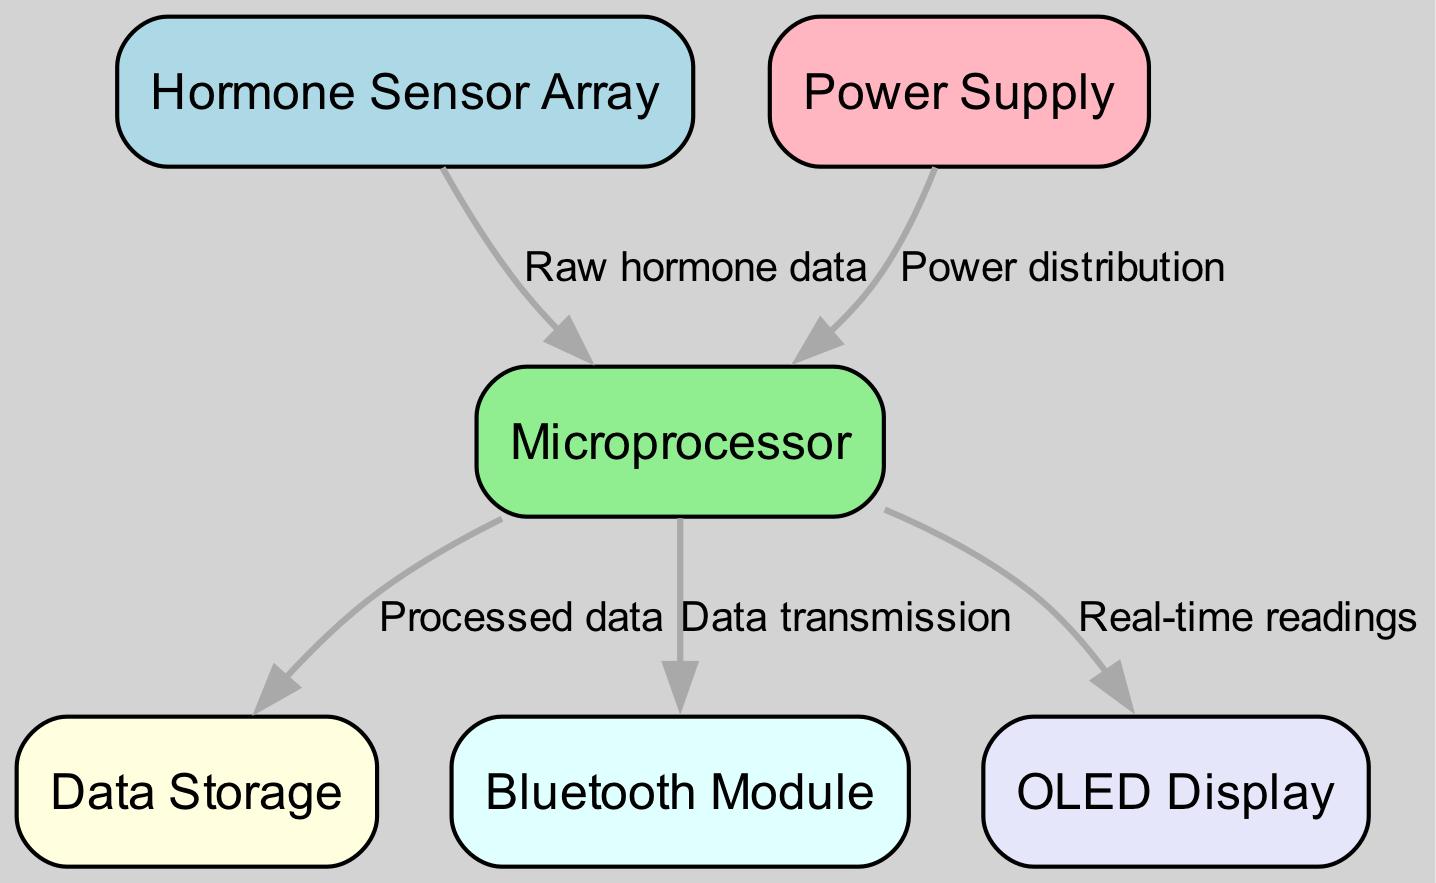What is the label of the node that stores data? The node that stores data is labeled "Data Storage" according to the node definitions provided in the diagram.
Answer: Data Storage How many nodes are present in the diagram? The diagram contains six nodes: Hormone Sensor Array, Microprocessor, Data Storage, Power Supply, Bluetooth Module, and OLED Display.
Answer: Six What type of data is sent from the sensor to the processor? The edge between the sensor and the processor is labeled "Raw hormone data," indicating the type of data being transmitted.
Answer: Raw hormone data Which node controls the data transmission to the Bluetooth module? The data transmission to the Bluetooth module is controlled by the "Microprocessor" as indicated by the directed edge leading to the Bluetooth module from the processor.
Answer: Microprocessor What color represents the Power Supply in the diagram? The Power Supply node is colored light pink, which is specified in the node style definitions within the diagram.
Answer: Light pink What does the OLED Display show? The OLED Display shows "Real-time readings" as indicated by the edge labeled accordingly from the processor to the display.
Answer: Real-time readings Describe the flow of data starting from the Hormone Sensor Array. The flow of data starts at the Hormone Sensor Array, which sends raw hormone data to the Microprocessor. The Microprocessor then processes this data to store it in Data Storage, displays real-time readings on the OLED Display, and transmits data via the Bluetooth Module.
Answer: Hormone Sensor Array to Microprocessor to Data Storage, OLED Display, and Bluetooth Module How is the Microprocessor powered? The Microprocessor receives power from the Power Supply node, as indicated by the directed edge labeled "Power distribution" leading to the processor.
Answer: Power Supply Which component receives processed data from the Microprocessor? The Data Storage component receives processed data from the Microprocessor according to the edge identified in the diagram.
Answer: Data Storage 